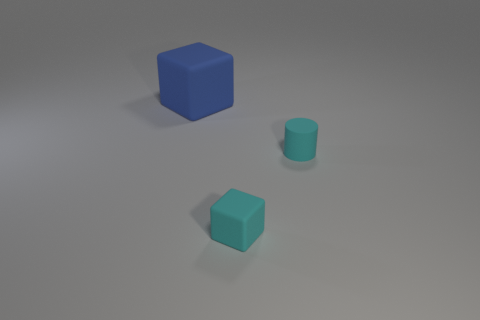Are there any other things that are the same size as the blue matte thing?
Offer a terse response. No. Are there more small cyan matte blocks that are to the left of the blue rubber object than small cylinders that are behind the tiny cylinder?
Keep it short and to the point. No. Is the size of the blue thing the same as the cyan matte block?
Offer a very short reply. No. How many matte objects are the same color as the tiny matte cylinder?
Your answer should be compact. 1. Is the number of things that are to the left of the blue block greater than the number of cyan matte cylinders?
Your response must be concise. No. There is a tiny rubber thing that is behind the tiny cyan rubber thing in front of the small cylinder; what color is it?
Offer a very short reply. Cyan. What number of objects are either cubes that are left of the small matte block or small rubber objects that are on the right side of the tiny rubber cube?
Your answer should be compact. 2. What is the color of the small rubber cylinder?
Offer a terse response. Cyan. What number of big gray objects have the same material as the cyan block?
Your response must be concise. 0. Is the number of small cyan things greater than the number of cyan spheres?
Your answer should be very brief. Yes. 